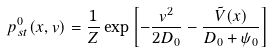Convert formula to latex. <formula><loc_0><loc_0><loc_500><loc_500>p _ { s t } ^ { 0 } ( x , v ) = \frac { 1 } { Z } \exp \left [ - \frac { v ^ { 2 } } { 2 D _ { 0 } } - \frac { \tilde { V } ( x ) } { D _ { 0 } + \psi _ { 0 } } \right ]</formula> 